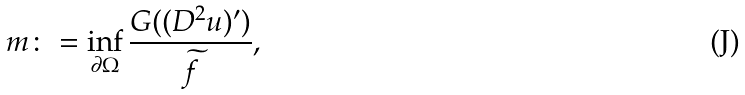Convert formula to latex. <formula><loc_0><loc_0><loc_500><loc_500>m \colon = \inf _ { \partial \Omega } \frac { G ( ( D ^ { 2 } u ) ^ { \prime } ) } { \widetilde { f } } ,</formula> 